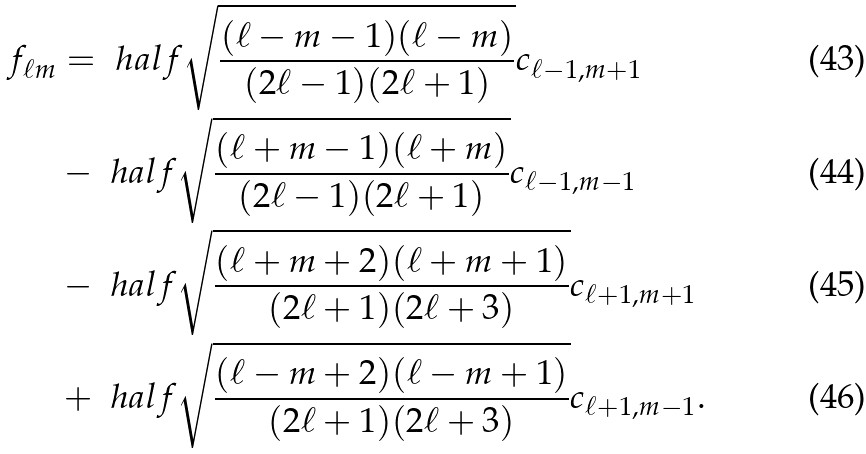Convert formula to latex. <formula><loc_0><loc_0><loc_500><loc_500>f _ { \ell m } & = \ h a l f \sqrt { \frac { ( \ell - m - 1 ) ( \ell - m ) } { ( 2 \ell - 1 ) ( 2 \ell + 1 ) } } c _ { \ell - 1 , m + 1 } \\ & - \ h a l f \sqrt { \frac { ( \ell + m - 1 ) ( \ell + m ) } { ( 2 \ell - 1 ) ( 2 \ell + 1 ) } } c _ { \ell - 1 , m - 1 } \\ & - \ h a l f \sqrt { \frac { ( \ell + m + 2 ) ( \ell + m + 1 ) } { ( 2 \ell + 1 ) ( 2 \ell + 3 ) } } c _ { \ell + 1 , m + 1 } \\ & + \ h a l f \sqrt { \frac { ( \ell - m + 2 ) ( \ell - m + 1 ) } { ( 2 \ell + 1 ) ( 2 \ell + 3 ) } } c _ { \ell + 1 , m - 1 } .</formula> 